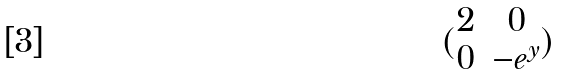Convert formula to latex. <formula><loc_0><loc_0><loc_500><loc_500>( \begin{matrix} 2 & 0 \\ 0 & - e ^ { y } \end{matrix} )</formula> 